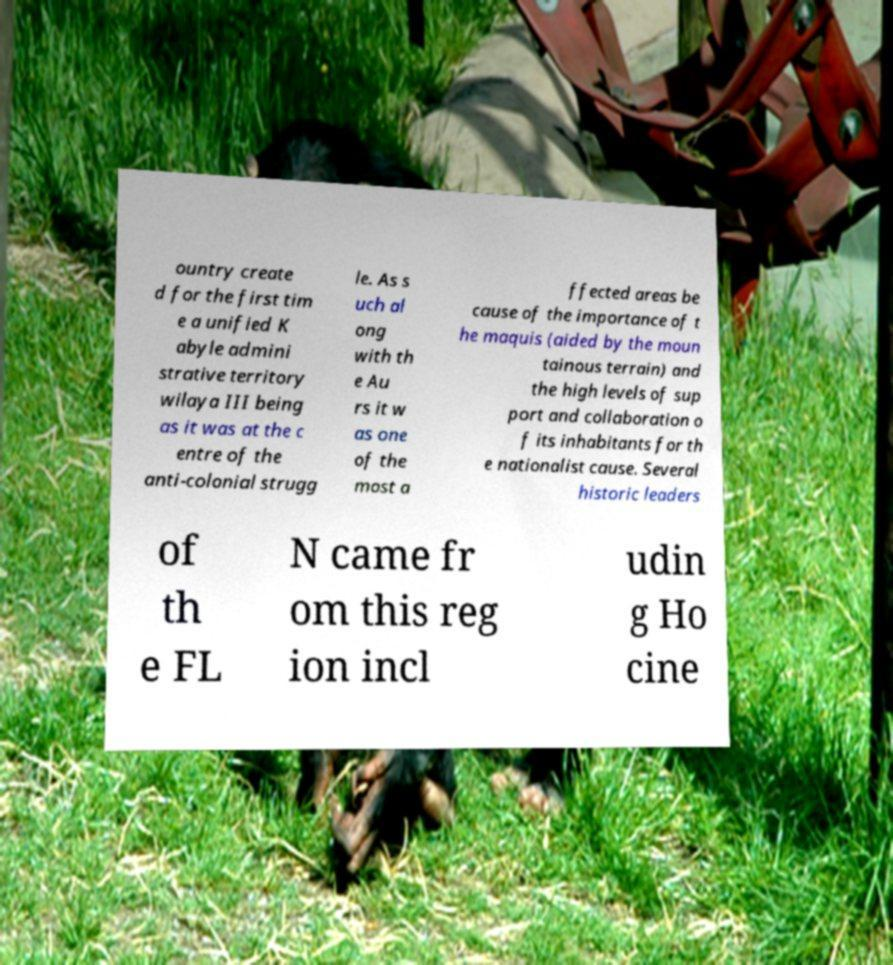What messages or text are displayed in this image? I need them in a readable, typed format. ountry create d for the first tim e a unified K abyle admini strative territory wilaya III being as it was at the c entre of the anti-colonial strugg le. As s uch al ong with th e Au rs it w as one of the most a ffected areas be cause of the importance of t he maquis (aided by the moun tainous terrain) and the high levels of sup port and collaboration o f its inhabitants for th e nationalist cause. Several historic leaders of th e FL N came fr om this reg ion incl udin g Ho cine 